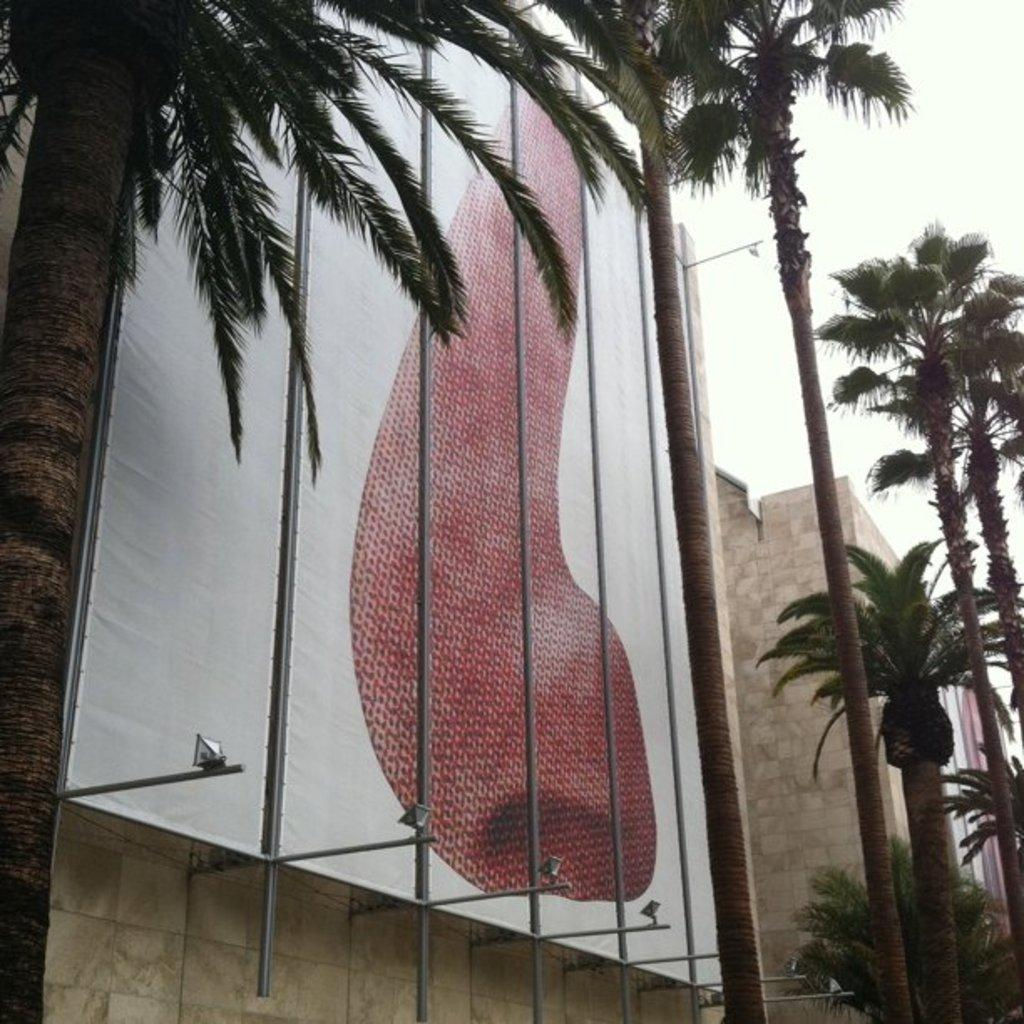What is located in the middle of the image? There are trees in the middle of the image. What is behind the trees in the image? There is a building behind the trees. What is on the building in the image? There is a banner on the building. What can be seen in the top right corner of the image? The sky is visible in the top right corner of the image. What type of leather can be seen on the pig in the image? There is no pig or leather present in the image. 